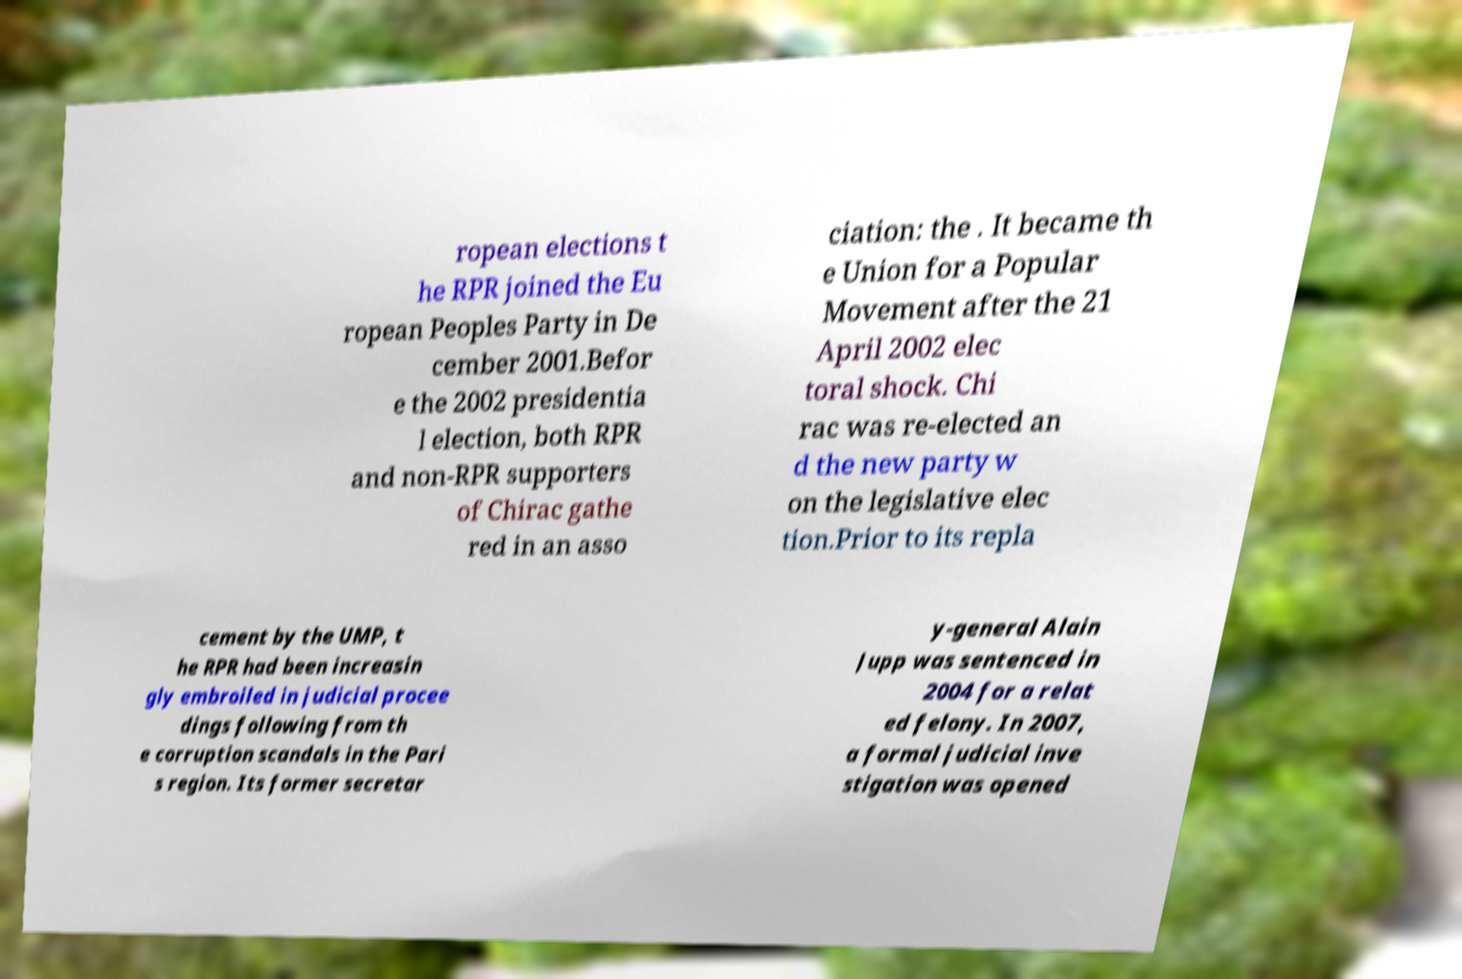Please read and relay the text visible in this image. What does it say? ropean elections t he RPR joined the Eu ropean Peoples Party in De cember 2001.Befor e the 2002 presidentia l election, both RPR and non-RPR supporters of Chirac gathe red in an asso ciation: the . It became th e Union for a Popular Movement after the 21 April 2002 elec toral shock. Chi rac was re-elected an d the new party w on the legislative elec tion.Prior to its repla cement by the UMP, t he RPR had been increasin gly embroiled in judicial procee dings following from th e corruption scandals in the Pari s region. Its former secretar y-general Alain Jupp was sentenced in 2004 for a relat ed felony. In 2007, a formal judicial inve stigation was opened 